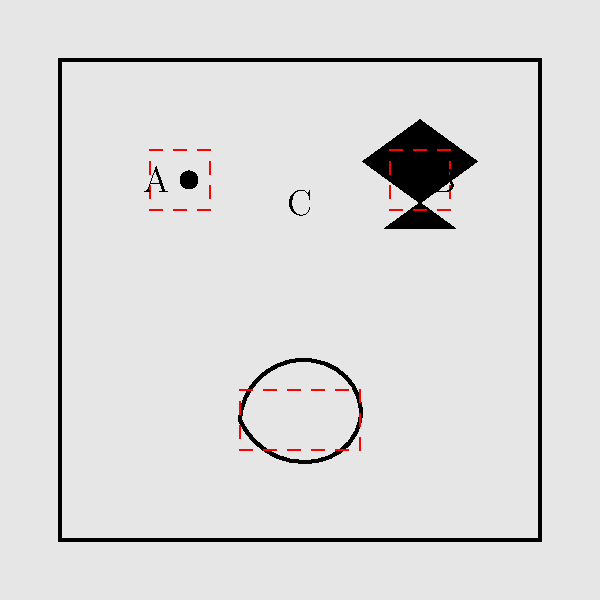In a computer vision system designed to detect political symbols in street murals, which of the following approaches would be most effective for identifying and localizing the symbols shown in the image, while also being robust to variations in artistic style and mural composition?

A) Template matching
B) Region-based Convolutional Neural Networks (R-CNN)
C) Fully Convolutional Networks (FCN)
D) You-Only-Look-Once (YOLO) architecture To determine the most effective approach for detecting political symbols in street murals, let's consider each option:

1. Template matching:
   - Pros: Simple to implement, works well for fixed patterns
   - Cons: Not robust to variations in scale, rotation, or artistic style
   - Not suitable for this complex task with diverse symbols

2. Region-based Convolutional Neural Networks (R-CNN):
   - Pros: Accurate object detection and localization
   - Cons: Slow processing speed, multi-stage pipeline
   - While accurate, it may be too slow for real-time mural analysis

3. Fully Convolutional Networks (FCN):
   - Pros: Efficient for semantic segmentation
   - Cons: May not provide precise bounding boxes for individual symbols
   - Better suited for identifying regions rather than specific symbols

4. You-Only-Look-Once (YOLO) architecture:
   - Pros: Fast, real-time object detection with bounding boxes
   - Cons: May sacrifice some accuracy for speed
   - Well-suited for detecting multiple symbols in a single pass

Considering the requirements:
a) Need to detect multiple symbols (fist, star, dove) in a single image
b) Symbols may vary in style, size, and orientation across different murals
c) Real-time processing is desirable for analyzing multiple murals quickly
d) Precise localization of symbols is important for further analysis

The YOLO architecture (option D) is the most suitable approach because:
1. It can detect multiple objects (symbols) in a single forward pass of the network
2. It provides bounding boxes for localization, as shown in the image
3. It's fast enough for real-time processing of multiple murals
4. It can be trained to be robust to variations in artistic style and symbol representation

While R-CNN might provide slightly higher accuracy, the speed advantage of YOLO makes it more practical for this application, especially when dealing with a large number of murals in various locations.
Answer: You-Only-Look-Once (YOLO) architecture 